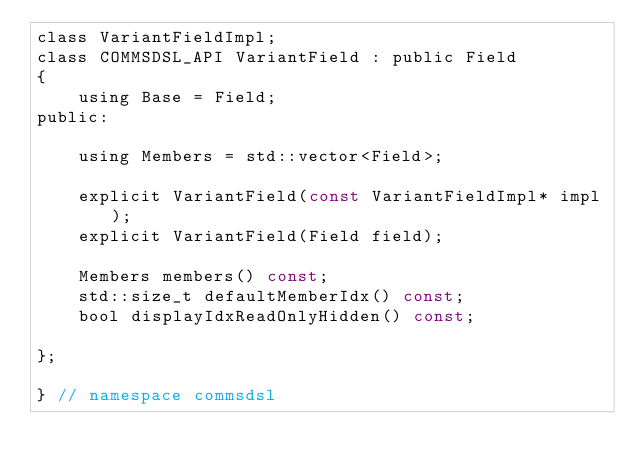<code> <loc_0><loc_0><loc_500><loc_500><_C_>class VariantFieldImpl;
class COMMSDSL_API VariantField : public Field
{
    using Base = Field;
public:

    using Members = std::vector<Field>;

    explicit VariantField(const VariantFieldImpl* impl);
    explicit VariantField(Field field);

    Members members() const;
    std::size_t defaultMemberIdx() const;
    bool displayIdxReadOnlyHidden() const;

};

} // namespace commsdsl
</code> 